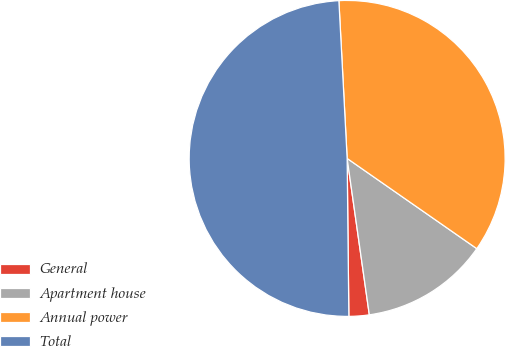<chart> <loc_0><loc_0><loc_500><loc_500><pie_chart><fcel>General<fcel>Apartment house<fcel>Annual power<fcel>Total<nl><fcel>2.07%<fcel>13.08%<fcel>35.51%<fcel>49.34%<nl></chart> 